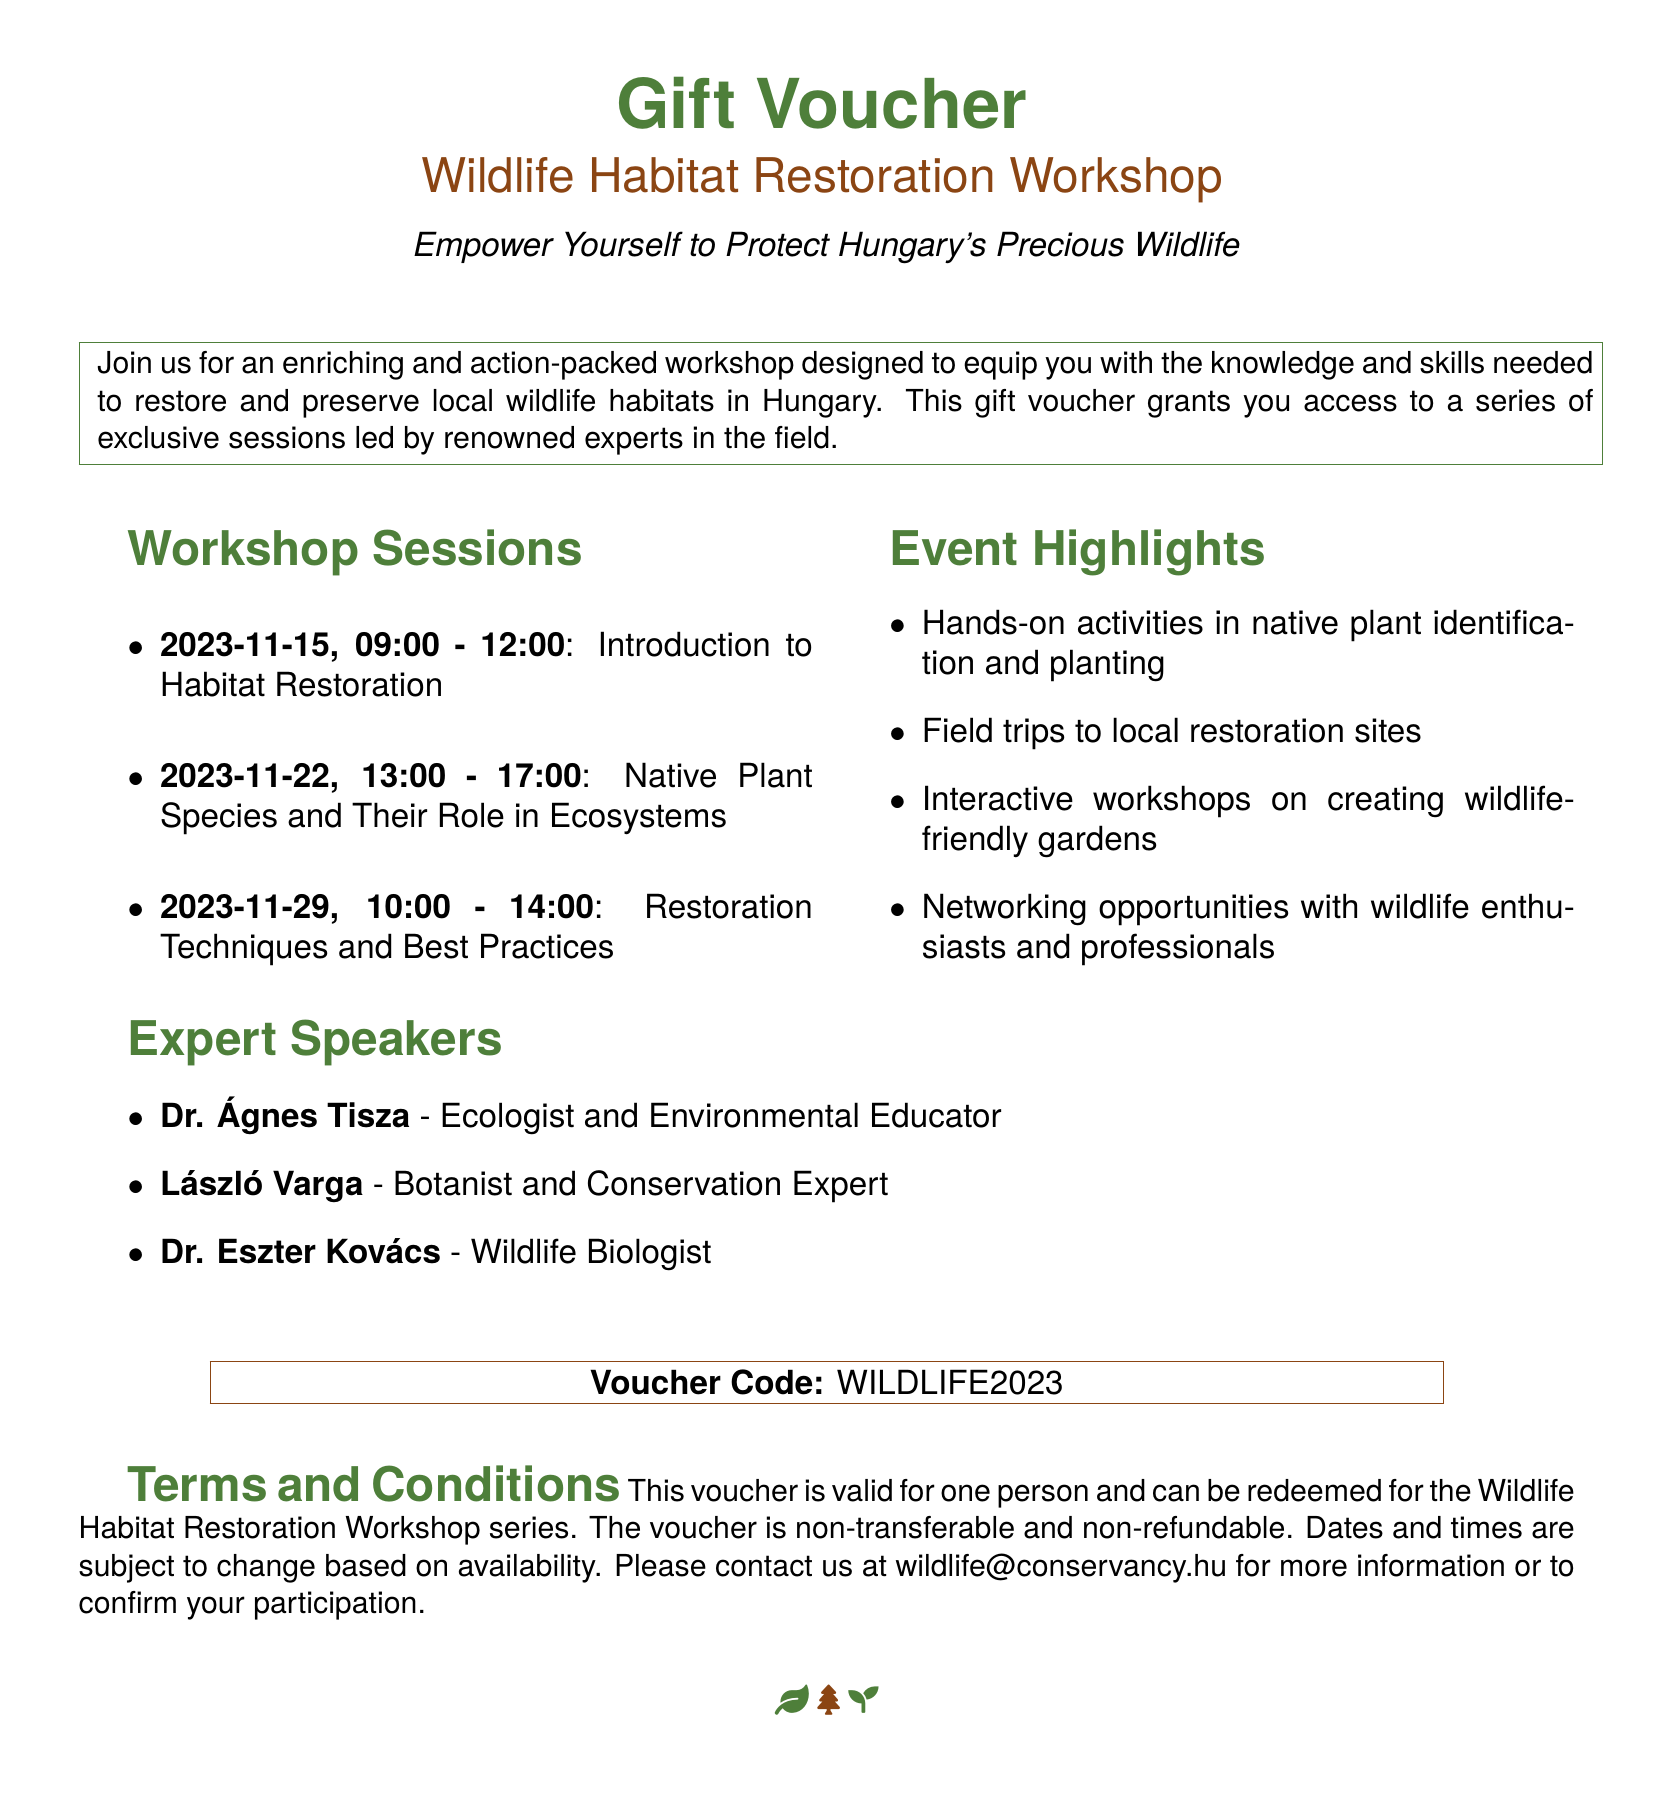What is the date and time for the first workshop session? The first workshop session is on November 15, 2023, from 09:00 to 12:00.
Answer: November 15, 2023, 09:00 - 12:00 Who is the speaker for the session on native plant species? The speaker for the session on native plant species is László Varga.
Answer: László Varga How many workshop sessions are listed in the document? The document lists three workshop sessions.
Answer: Three What type of activities will be included in the workshop? The workshop includes hands-on activities in native plant identification and planting, among others.
Answer: Hands-on activities Is the voucher transferable? The voucher is explicitly stated to be non-transferable.
Answer: Non-transferable What is the voucher code provided in the document? The voucher code provided is WILDLIFE2023.
Answer: WILDLIFE2023 What is one highlight of the event mentioned in the document? One highlight is the field trips to local restoration sites.
Answer: Field trips to local restoration sites When is the workshop focused on restoration techniques scheduled? The workshop on restoration techniques is scheduled for November 29, 2023, from 10:00 to 14:00.
Answer: November 29, 2023, 10:00 - 14:00 